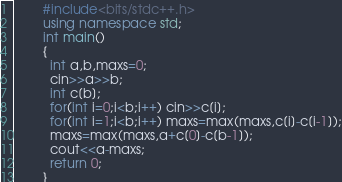Convert code to text. <code><loc_0><loc_0><loc_500><loc_500><_C++_>        #include<bits/stdc++.h>
        using namespace std;
        int main()
        {
          int a,b,maxs=0;
          cin>>a>>b;
          int c[b];
          for(int i=0;i<b;i++) cin>>c[i];
          for(int i=1;i<b;i++) maxs=max(maxs,c[i]-c[i-1]);
          maxs=max(maxs,a+c[0]-c[b-1]);
          cout<<a-maxs;
          return 0;
        }</code> 